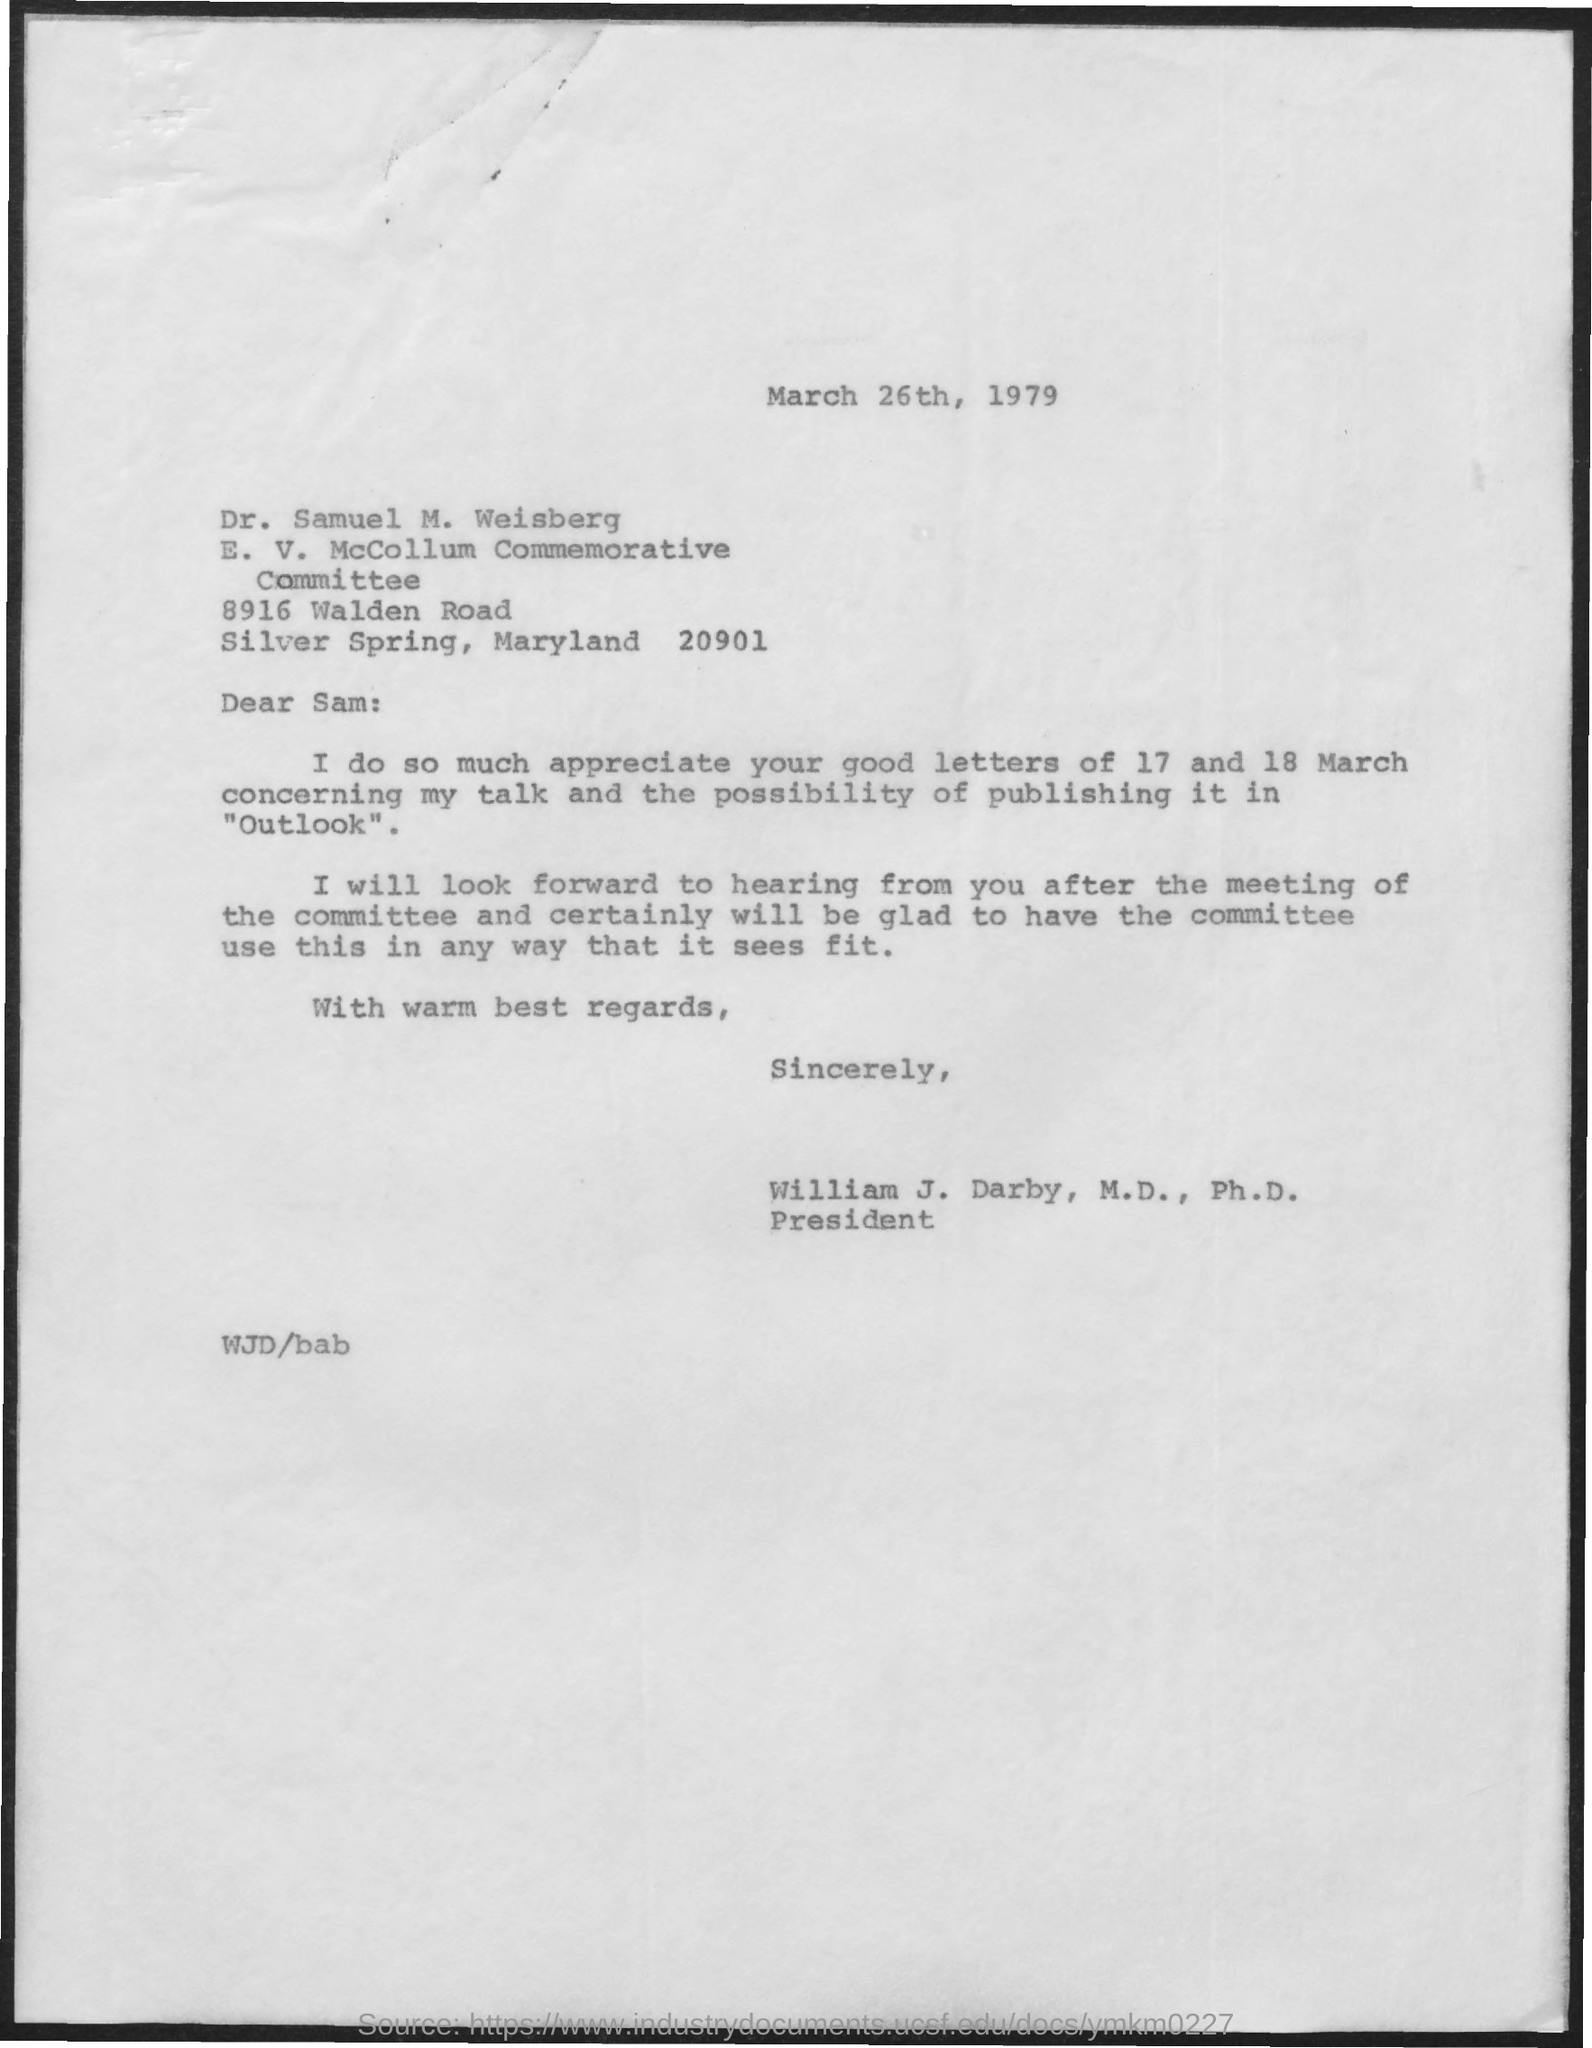To whom is the letter addressed?
Offer a terse response. Sam. Who is the sender?
Your response must be concise. William J. Darby. 